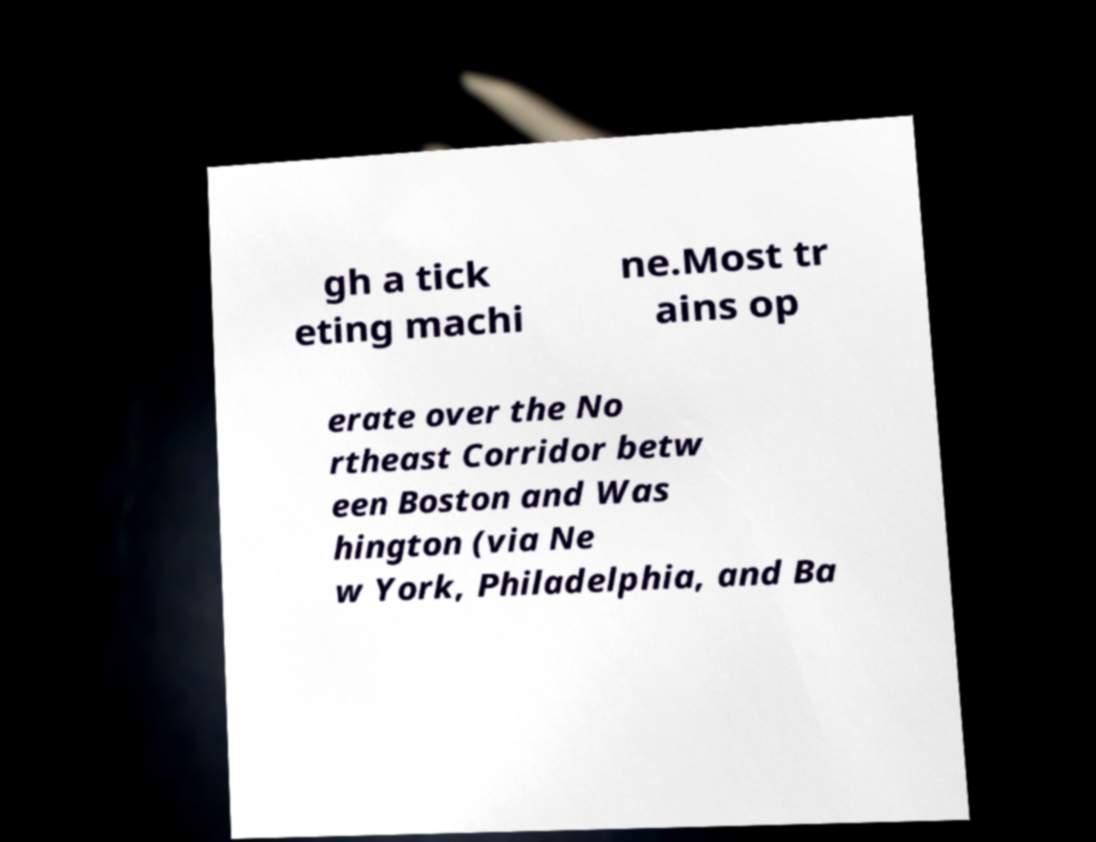I need the written content from this picture converted into text. Can you do that? gh a tick eting machi ne.Most tr ains op erate over the No rtheast Corridor betw een Boston and Was hington (via Ne w York, Philadelphia, and Ba 